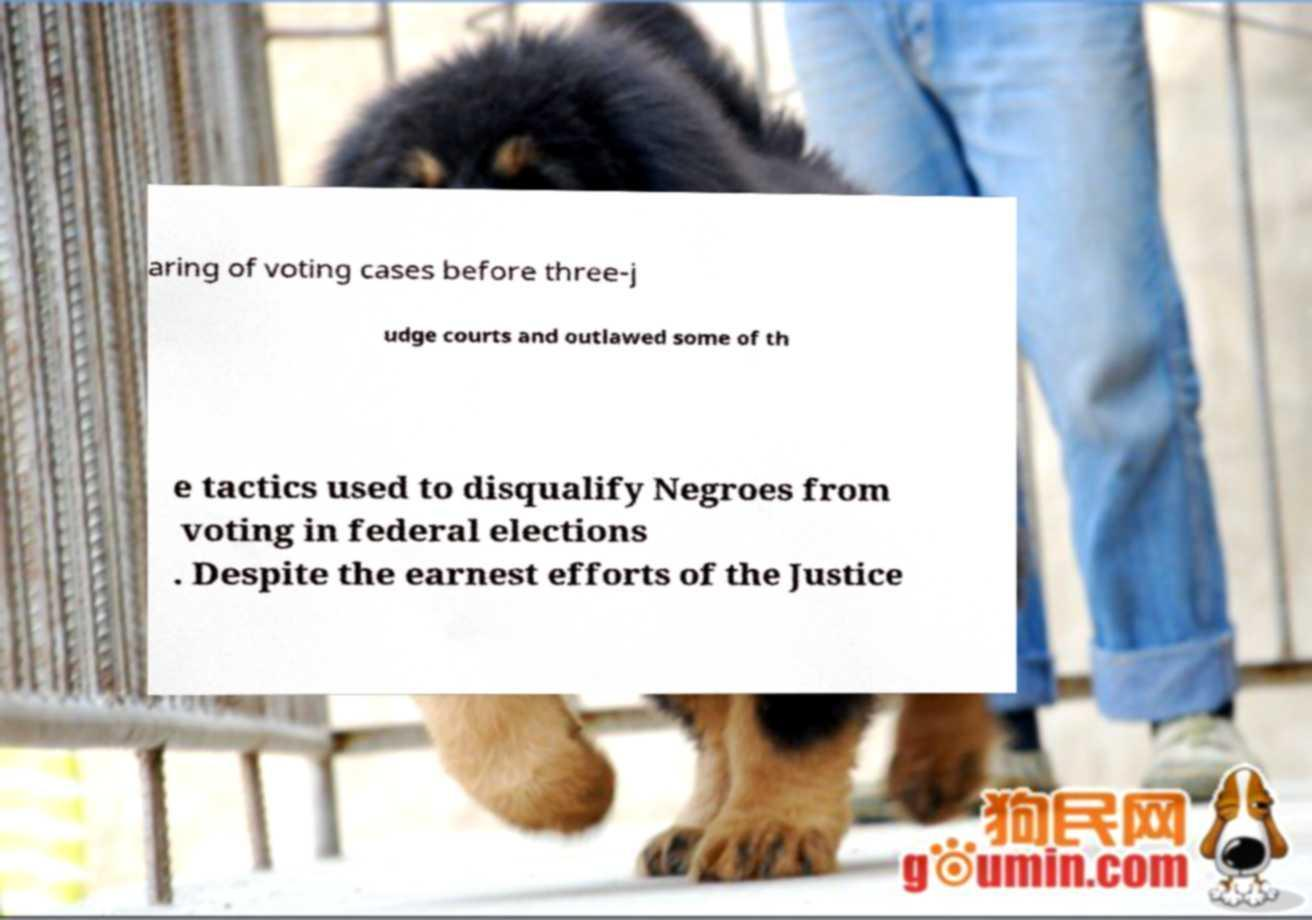Could you extract and type out the text from this image? aring of voting cases before three-j udge courts and outlawed some of th e tactics used to disqualify Negroes from voting in federal elections . Despite the earnest efforts of the Justice 